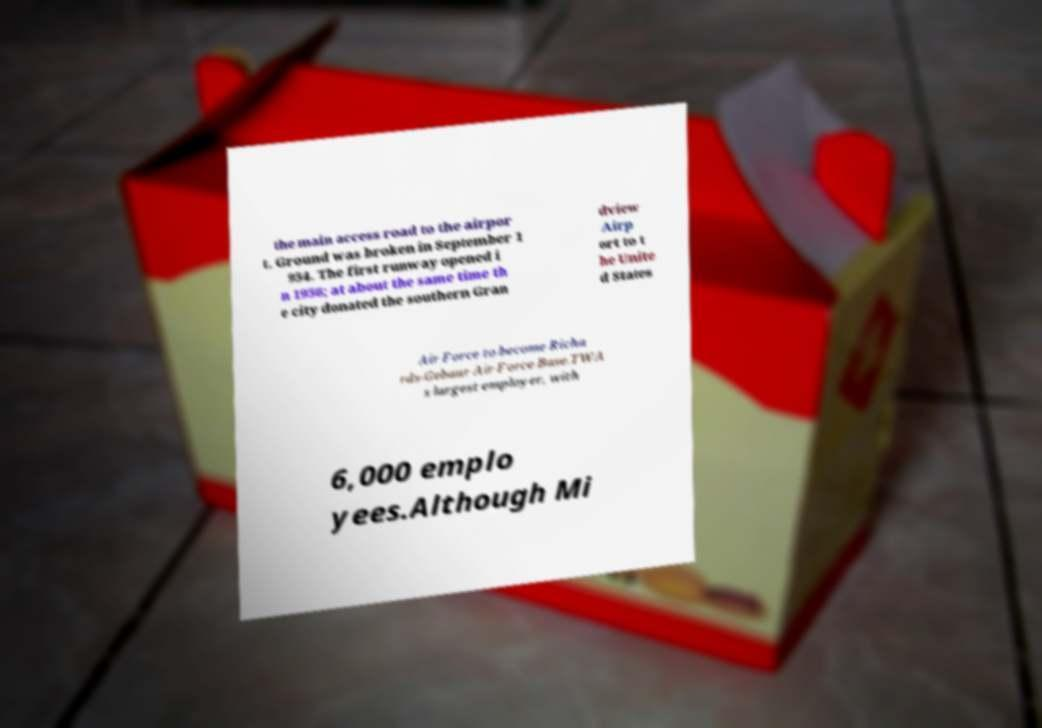Please read and relay the text visible in this image. What does it say? the main access road to the airpor t. Ground was broken in September 1 954. The first runway opened i n 1956; at about the same time th e city donated the southern Gran dview Airp ort to t he Unite d States Air Force to become Richa rds-Gebaur Air Force Base.TWA s largest employer, with 6,000 emplo yees.Although Mi 